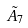<formula> <loc_0><loc_0><loc_500><loc_500>\tilde { A } _ { 7 }</formula> 